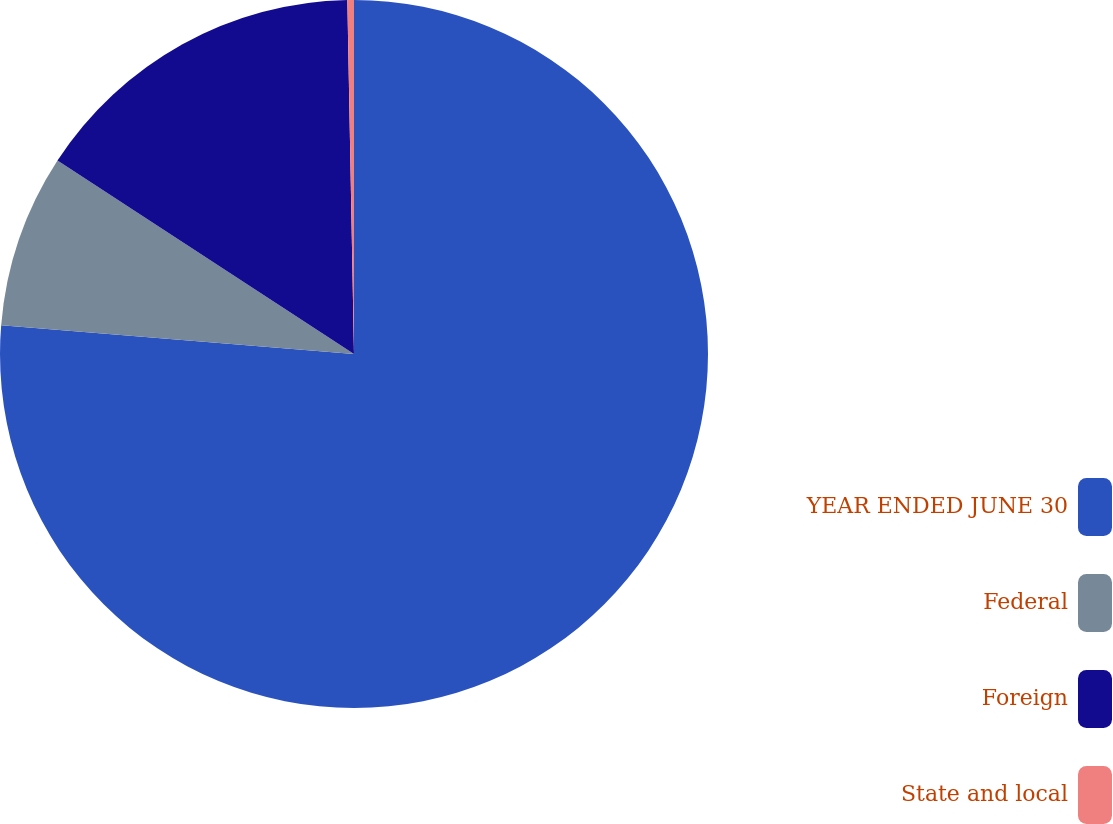Convert chart. <chart><loc_0><loc_0><loc_500><loc_500><pie_chart><fcel>YEAR ENDED JUNE 30<fcel>Federal<fcel>Foreign<fcel>State and local<nl><fcel>76.29%<fcel>7.9%<fcel>15.5%<fcel>0.3%<nl></chart> 